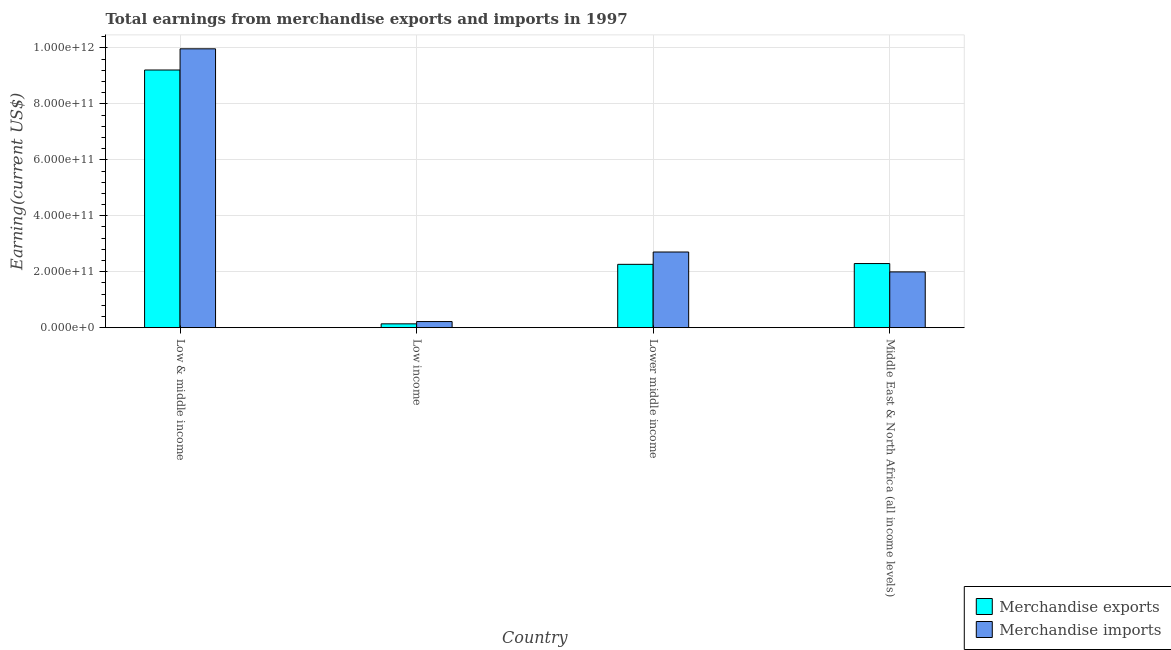Are the number of bars per tick equal to the number of legend labels?
Offer a terse response. Yes. Are the number of bars on each tick of the X-axis equal?
Provide a succinct answer. Yes. How many bars are there on the 2nd tick from the left?
Give a very brief answer. 2. What is the label of the 3rd group of bars from the left?
Provide a short and direct response. Lower middle income. What is the earnings from merchandise exports in Middle East & North Africa (all income levels)?
Offer a terse response. 2.29e+11. Across all countries, what is the maximum earnings from merchandise imports?
Provide a succinct answer. 9.97e+11. Across all countries, what is the minimum earnings from merchandise exports?
Offer a very short reply. 1.37e+1. What is the total earnings from merchandise exports in the graph?
Your answer should be compact. 1.39e+12. What is the difference between the earnings from merchandise imports in Low & middle income and that in Lower middle income?
Give a very brief answer. 7.26e+11. What is the difference between the earnings from merchandise imports in Low & middle income and the earnings from merchandise exports in Middle East & North Africa (all income levels)?
Offer a very short reply. 7.68e+11. What is the average earnings from merchandise imports per country?
Provide a short and direct response. 3.72e+11. What is the difference between the earnings from merchandise imports and earnings from merchandise exports in Lower middle income?
Provide a short and direct response. 4.41e+1. In how many countries, is the earnings from merchandise exports greater than 840000000000 US$?
Offer a very short reply. 1. What is the ratio of the earnings from merchandise imports in Low & middle income to that in Middle East & North Africa (all income levels)?
Keep it short and to the point. 5. Is the difference between the earnings from merchandise exports in Low income and Lower middle income greater than the difference between the earnings from merchandise imports in Low income and Lower middle income?
Your answer should be compact. Yes. What is the difference between the highest and the second highest earnings from merchandise exports?
Your answer should be compact. 6.92e+11. What is the difference between the highest and the lowest earnings from merchandise exports?
Your answer should be very brief. 9.07e+11. In how many countries, is the earnings from merchandise exports greater than the average earnings from merchandise exports taken over all countries?
Your answer should be compact. 1. What does the 2nd bar from the left in Low & middle income represents?
Keep it short and to the point. Merchandise imports. Are all the bars in the graph horizontal?
Offer a terse response. No. How many countries are there in the graph?
Give a very brief answer. 4. What is the difference between two consecutive major ticks on the Y-axis?
Provide a succinct answer. 2.00e+11. Where does the legend appear in the graph?
Your response must be concise. Bottom right. How many legend labels are there?
Keep it short and to the point. 2. What is the title of the graph?
Ensure brevity in your answer.  Total earnings from merchandise exports and imports in 1997. What is the label or title of the Y-axis?
Your response must be concise. Earning(current US$). What is the Earning(current US$) in Merchandise exports in Low & middle income?
Offer a very short reply. 9.21e+11. What is the Earning(current US$) of Merchandise imports in Low & middle income?
Make the answer very short. 9.97e+11. What is the Earning(current US$) in Merchandise exports in Low income?
Make the answer very short. 1.37e+1. What is the Earning(current US$) of Merchandise imports in Low income?
Provide a succinct answer. 2.18e+1. What is the Earning(current US$) in Merchandise exports in Lower middle income?
Your response must be concise. 2.26e+11. What is the Earning(current US$) in Merchandise imports in Lower middle income?
Provide a short and direct response. 2.70e+11. What is the Earning(current US$) of Merchandise exports in Middle East & North Africa (all income levels)?
Your answer should be compact. 2.29e+11. What is the Earning(current US$) in Merchandise imports in Middle East & North Africa (all income levels)?
Offer a terse response. 1.99e+11. Across all countries, what is the maximum Earning(current US$) of Merchandise exports?
Offer a very short reply. 9.21e+11. Across all countries, what is the maximum Earning(current US$) in Merchandise imports?
Offer a very short reply. 9.97e+11. Across all countries, what is the minimum Earning(current US$) of Merchandise exports?
Offer a very short reply. 1.37e+1. Across all countries, what is the minimum Earning(current US$) of Merchandise imports?
Your answer should be compact. 2.18e+1. What is the total Earning(current US$) in Merchandise exports in the graph?
Your response must be concise. 1.39e+12. What is the total Earning(current US$) of Merchandise imports in the graph?
Your response must be concise. 1.49e+12. What is the difference between the Earning(current US$) in Merchandise exports in Low & middle income and that in Low income?
Make the answer very short. 9.07e+11. What is the difference between the Earning(current US$) in Merchandise imports in Low & middle income and that in Low income?
Make the answer very short. 9.75e+11. What is the difference between the Earning(current US$) of Merchandise exports in Low & middle income and that in Lower middle income?
Offer a terse response. 6.95e+11. What is the difference between the Earning(current US$) of Merchandise imports in Low & middle income and that in Lower middle income?
Your answer should be very brief. 7.26e+11. What is the difference between the Earning(current US$) in Merchandise exports in Low & middle income and that in Middle East & North Africa (all income levels)?
Your answer should be very brief. 6.92e+11. What is the difference between the Earning(current US$) in Merchandise imports in Low & middle income and that in Middle East & North Africa (all income levels)?
Provide a short and direct response. 7.98e+11. What is the difference between the Earning(current US$) of Merchandise exports in Low income and that in Lower middle income?
Give a very brief answer. -2.13e+11. What is the difference between the Earning(current US$) in Merchandise imports in Low income and that in Lower middle income?
Keep it short and to the point. -2.49e+11. What is the difference between the Earning(current US$) of Merchandise exports in Low income and that in Middle East & North Africa (all income levels)?
Ensure brevity in your answer.  -2.16e+11. What is the difference between the Earning(current US$) of Merchandise imports in Low income and that in Middle East & North Africa (all income levels)?
Provide a succinct answer. -1.78e+11. What is the difference between the Earning(current US$) of Merchandise exports in Lower middle income and that in Middle East & North Africa (all income levels)?
Offer a very short reply. -2.76e+09. What is the difference between the Earning(current US$) of Merchandise imports in Lower middle income and that in Middle East & North Africa (all income levels)?
Offer a very short reply. 7.12e+1. What is the difference between the Earning(current US$) in Merchandise exports in Low & middle income and the Earning(current US$) in Merchandise imports in Low income?
Offer a terse response. 8.99e+11. What is the difference between the Earning(current US$) of Merchandise exports in Low & middle income and the Earning(current US$) of Merchandise imports in Lower middle income?
Your answer should be compact. 6.51e+11. What is the difference between the Earning(current US$) in Merchandise exports in Low & middle income and the Earning(current US$) in Merchandise imports in Middle East & North Africa (all income levels)?
Offer a terse response. 7.22e+11. What is the difference between the Earning(current US$) in Merchandise exports in Low income and the Earning(current US$) in Merchandise imports in Lower middle income?
Ensure brevity in your answer.  -2.57e+11. What is the difference between the Earning(current US$) of Merchandise exports in Low income and the Earning(current US$) of Merchandise imports in Middle East & North Africa (all income levels)?
Provide a succinct answer. -1.86e+11. What is the difference between the Earning(current US$) of Merchandise exports in Lower middle income and the Earning(current US$) of Merchandise imports in Middle East & North Africa (all income levels)?
Your response must be concise. 2.71e+1. What is the average Earning(current US$) of Merchandise exports per country?
Offer a terse response. 3.48e+11. What is the average Earning(current US$) of Merchandise imports per country?
Ensure brevity in your answer.  3.72e+11. What is the difference between the Earning(current US$) of Merchandise exports and Earning(current US$) of Merchandise imports in Low & middle income?
Provide a short and direct response. -7.57e+1. What is the difference between the Earning(current US$) of Merchandise exports and Earning(current US$) of Merchandise imports in Low income?
Ensure brevity in your answer.  -8.16e+09. What is the difference between the Earning(current US$) of Merchandise exports and Earning(current US$) of Merchandise imports in Lower middle income?
Offer a terse response. -4.41e+1. What is the difference between the Earning(current US$) in Merchandise exports and Earning(current US$) in Merchandise imports in Middle East & North Africa (all income levels)?
Make the answer very short. 2.98e+1. What is the ratio of the Earning(current US$) of Merchandise exports in Low & middle income to that in Low income?
Ensure brevity in your answer.  67.42. What is the ratio of the Earning(current US$) of Merchandise imports in Low & middle income to that in Low income?
Keep it short and to the point. 45.67. What is the ratio of the Earning(current US$) in Merchandise exports in Low & middle income to that in Lower middle income?
Offer a very short reply. 4.07. What is the ratio of the Earning(current US$) in Merchandise imports in Low & middle income to that in Lower middle income?
Give a very brief answer. 3.69. What is the ratio of the Earning(current US$) in Merchandise exports in Low & middle income to that in Middle East & North Africa (all income levels)?
Your answer should be very brief. 4.02. What is the ratio of the Earning(current US$) in Merchandise imports in Low & middle income to that in Middle East & North Africa (all income levels)?
Offer a terse response. 5. What is the ratio of the Earning(current US$) in Merchandise exports in Low income to that in Lower middle income?
Provide a succinct answer. 0.06. What is the ratio of the Earning(current US$) in Merchandise imports in Low income to that in Lower middle income?
Offer a very short reply. 0.08. What is the ratio of the Earning(current US$) in Merchandise exports in Low income to that in Middle East & North Africa (all income levels)?
Offer a very short reply. 0.06. What is the ratio of the Earning(current US$) of Merchandise imports in Low income to that in Middle East & North Africa (all income levels)?
Make the answer very short. 0.11. What is the ratio of the Earning(current US$) of Merchandise exports in Lower middle income to that in Middle East & North Africa (all income levels)?
Your response must be concise. 0.99. What is the ratio of the Earning(current US$) of Merchandise imports in Lower middle income to that in Middle East & North Africa (all income levels)?
Offer a very short reply. 1.36. What is the difference between the highest and the second highest Earning(current US$) in Merchandise exports?
Ensure brevity in your answer.  6.92e+11. What is the difference between the highest and the second highest Earning(current US$) of Merchandise imports?
Ensure brevity in your answer.  7.26e+11. What is the difference between the highest and the lowest Earning(current US$) of Merchandise exports?
Keep it short and to the point. 9.07e+11. What is the difference between the highest and the lowest Earning(current US$) of Merchandise imports?
Offer a very short reply. 9.75e+11. 